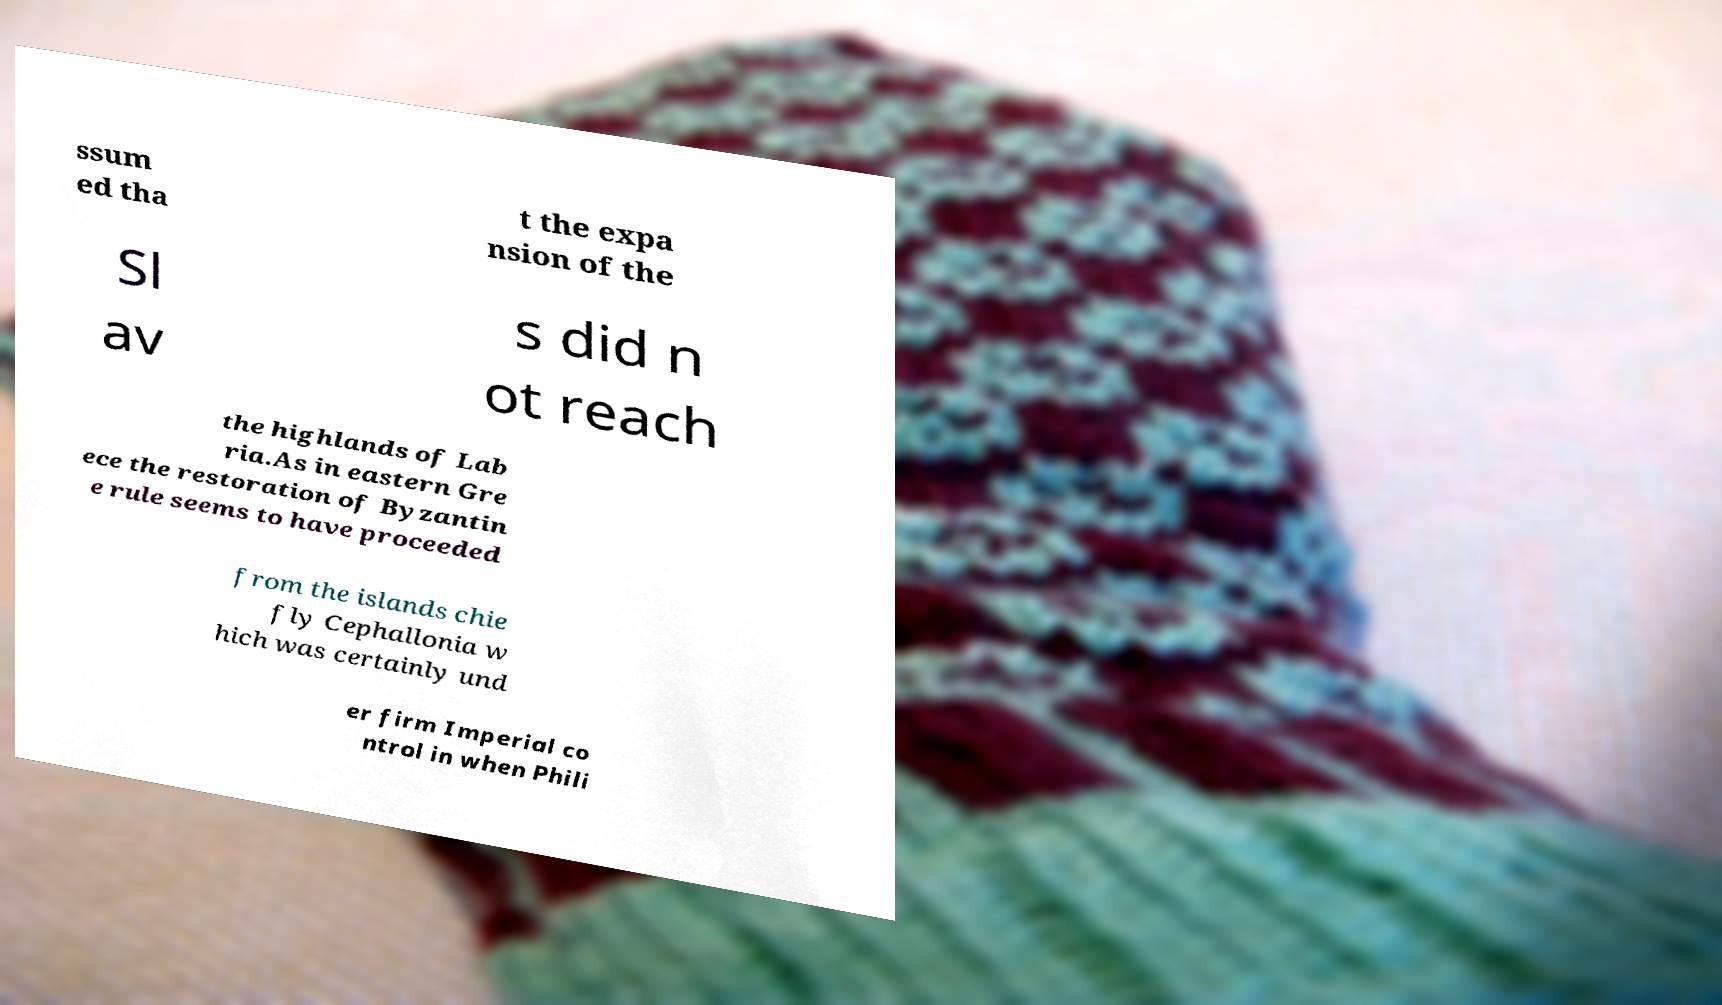Can you accurately transcribe the text from the provided image for me? ssum ed tha t the expa nsion of the Sl av s did n ot reach the highlands of Lab ria.As in eastern Gre ece the restoration of Byzantin e rule seems to have proceeded from the islands chie fly Cephallonia w hich was certainly und er firm Imperial co ntrol in when Phili 